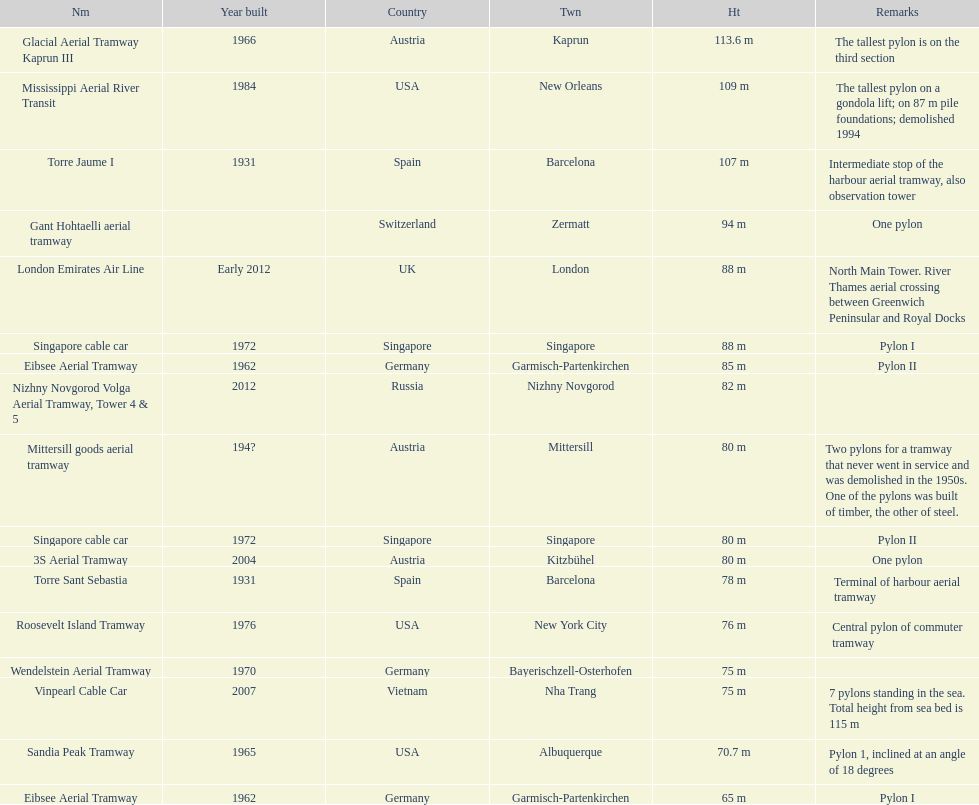The london emirates air line pylon has the same height as which pylon? Singapore cable car. 